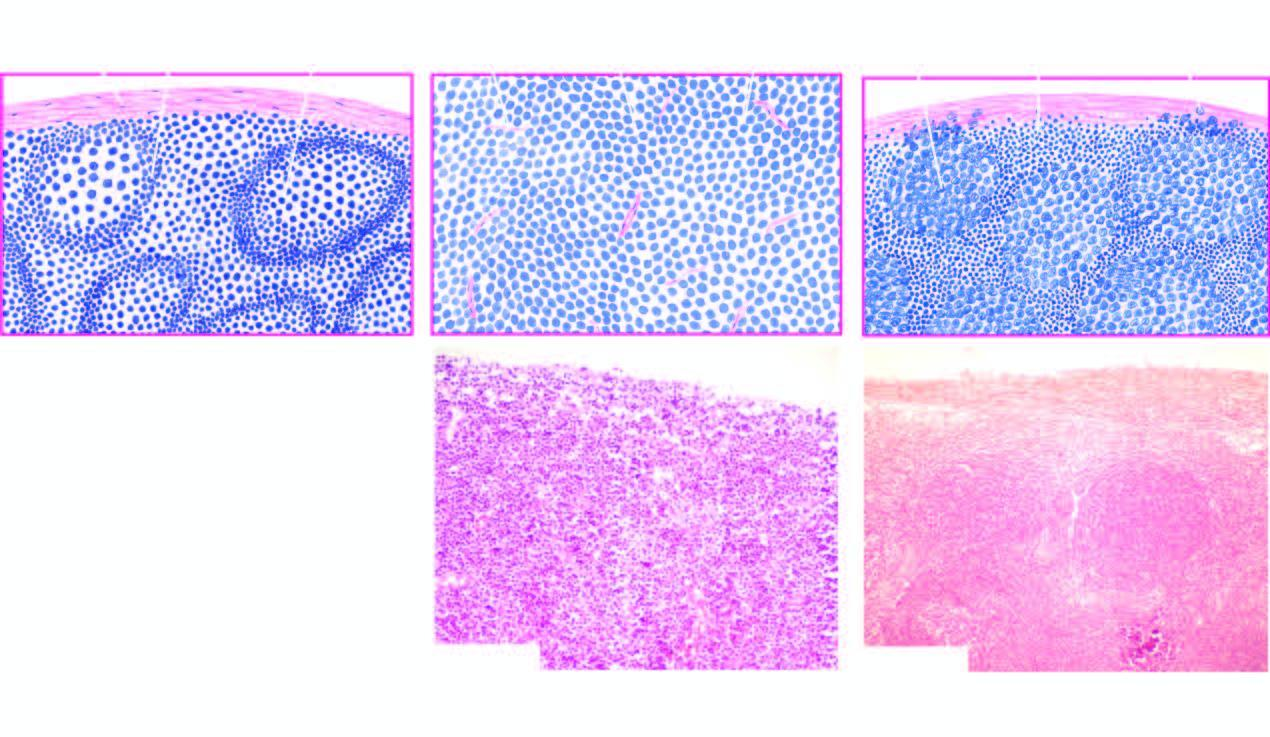what is contrasted with structure of normal lymph node a?
Answer the question using a single word or phrase. Follicular lymphoma 